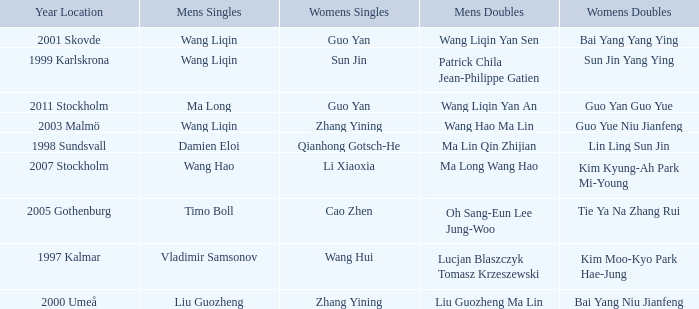How many times has Ma Long won the men's singles? 1.0. 